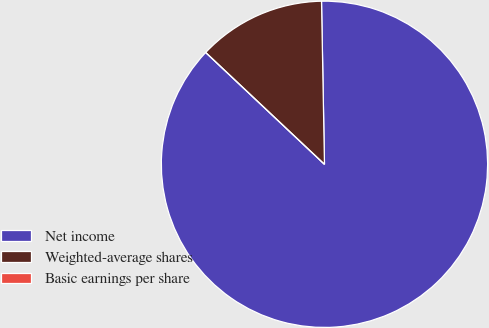<chart> <loc_0><loc_0><loc_500><loc_500><pie_chart><fcel>Net income<fcel>Weighted-average shares<fcel>Basic earnings per share<nl><fcel>87.31%<fcel>12.69%<fcel>0.0%<nl></chart> 